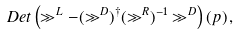Convert formula to latex. <formula><loc_0><loc_0><loc_500><loc_500>D e t \left ( \gg ^ { L } - ( \gg ^ { D } ) ^ { \dagger } ( \gg ^ { R } ) ^ { - 1 } \gg ^ { D } \right ) ( p ) \, ,</formula> 